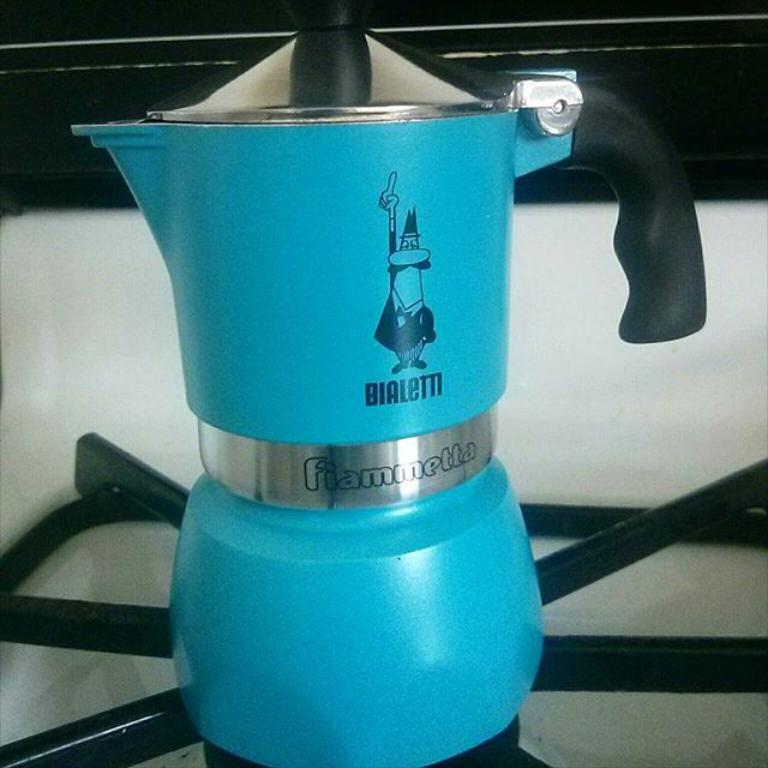<image>
Write a terse but informative summary of the picture. A tall blue tea kettle that has "Bialem" and "fiammetta" written on it. 